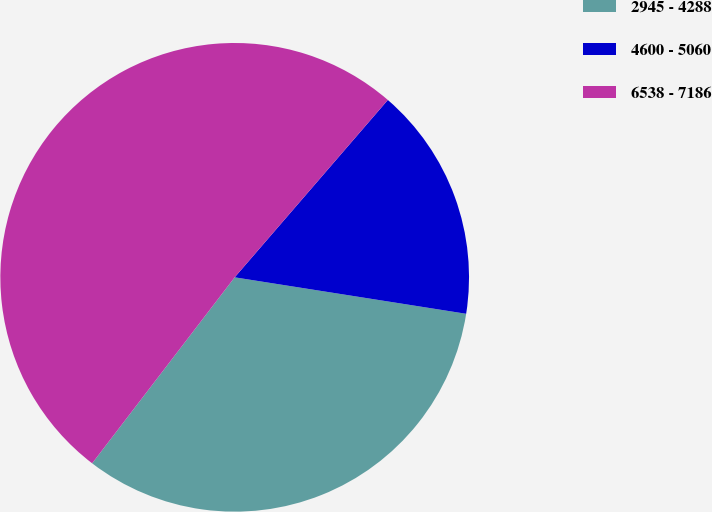Convert chart. <chart><loc_0><loc_0><loc_500><loc_500><pie_chart><fcel>2945 - 4288<fcel>4600 - 5060<fcel>6538 - 7186<nl><fcel>32.92%<fcel>16.15%<fcel>50.93%<nl></chart> 